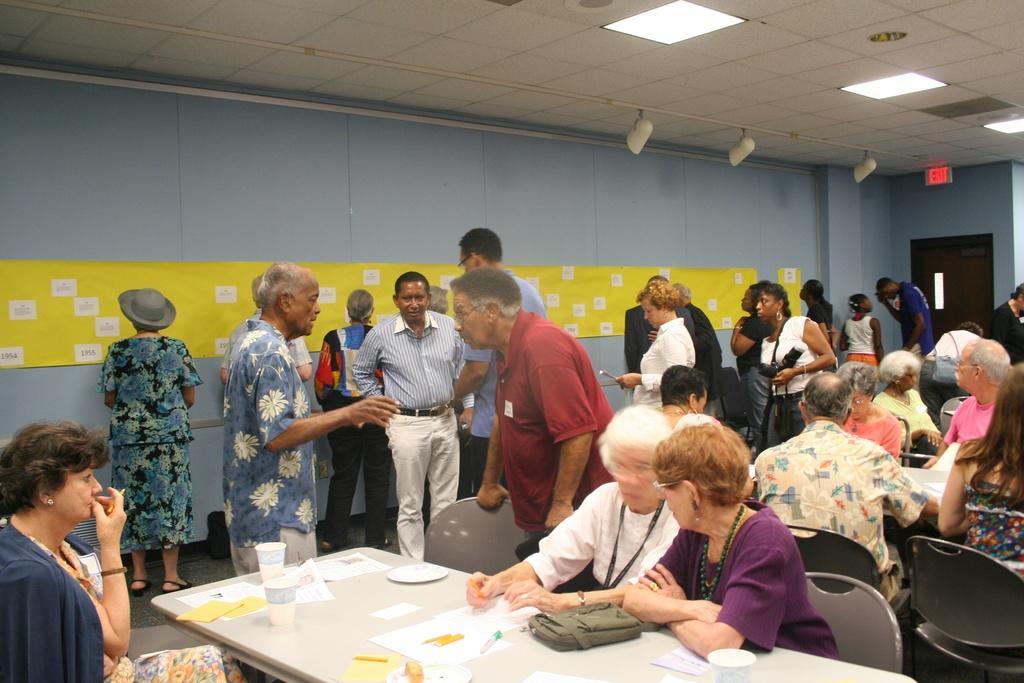In one or two sentences, can you explain what this image depicts? In the image there are people sitting on either side of table with papers,pens,bag and cups on it, on the back there are many people standing,walking and staring at the wall in the front and there are lights over the ceiling. 